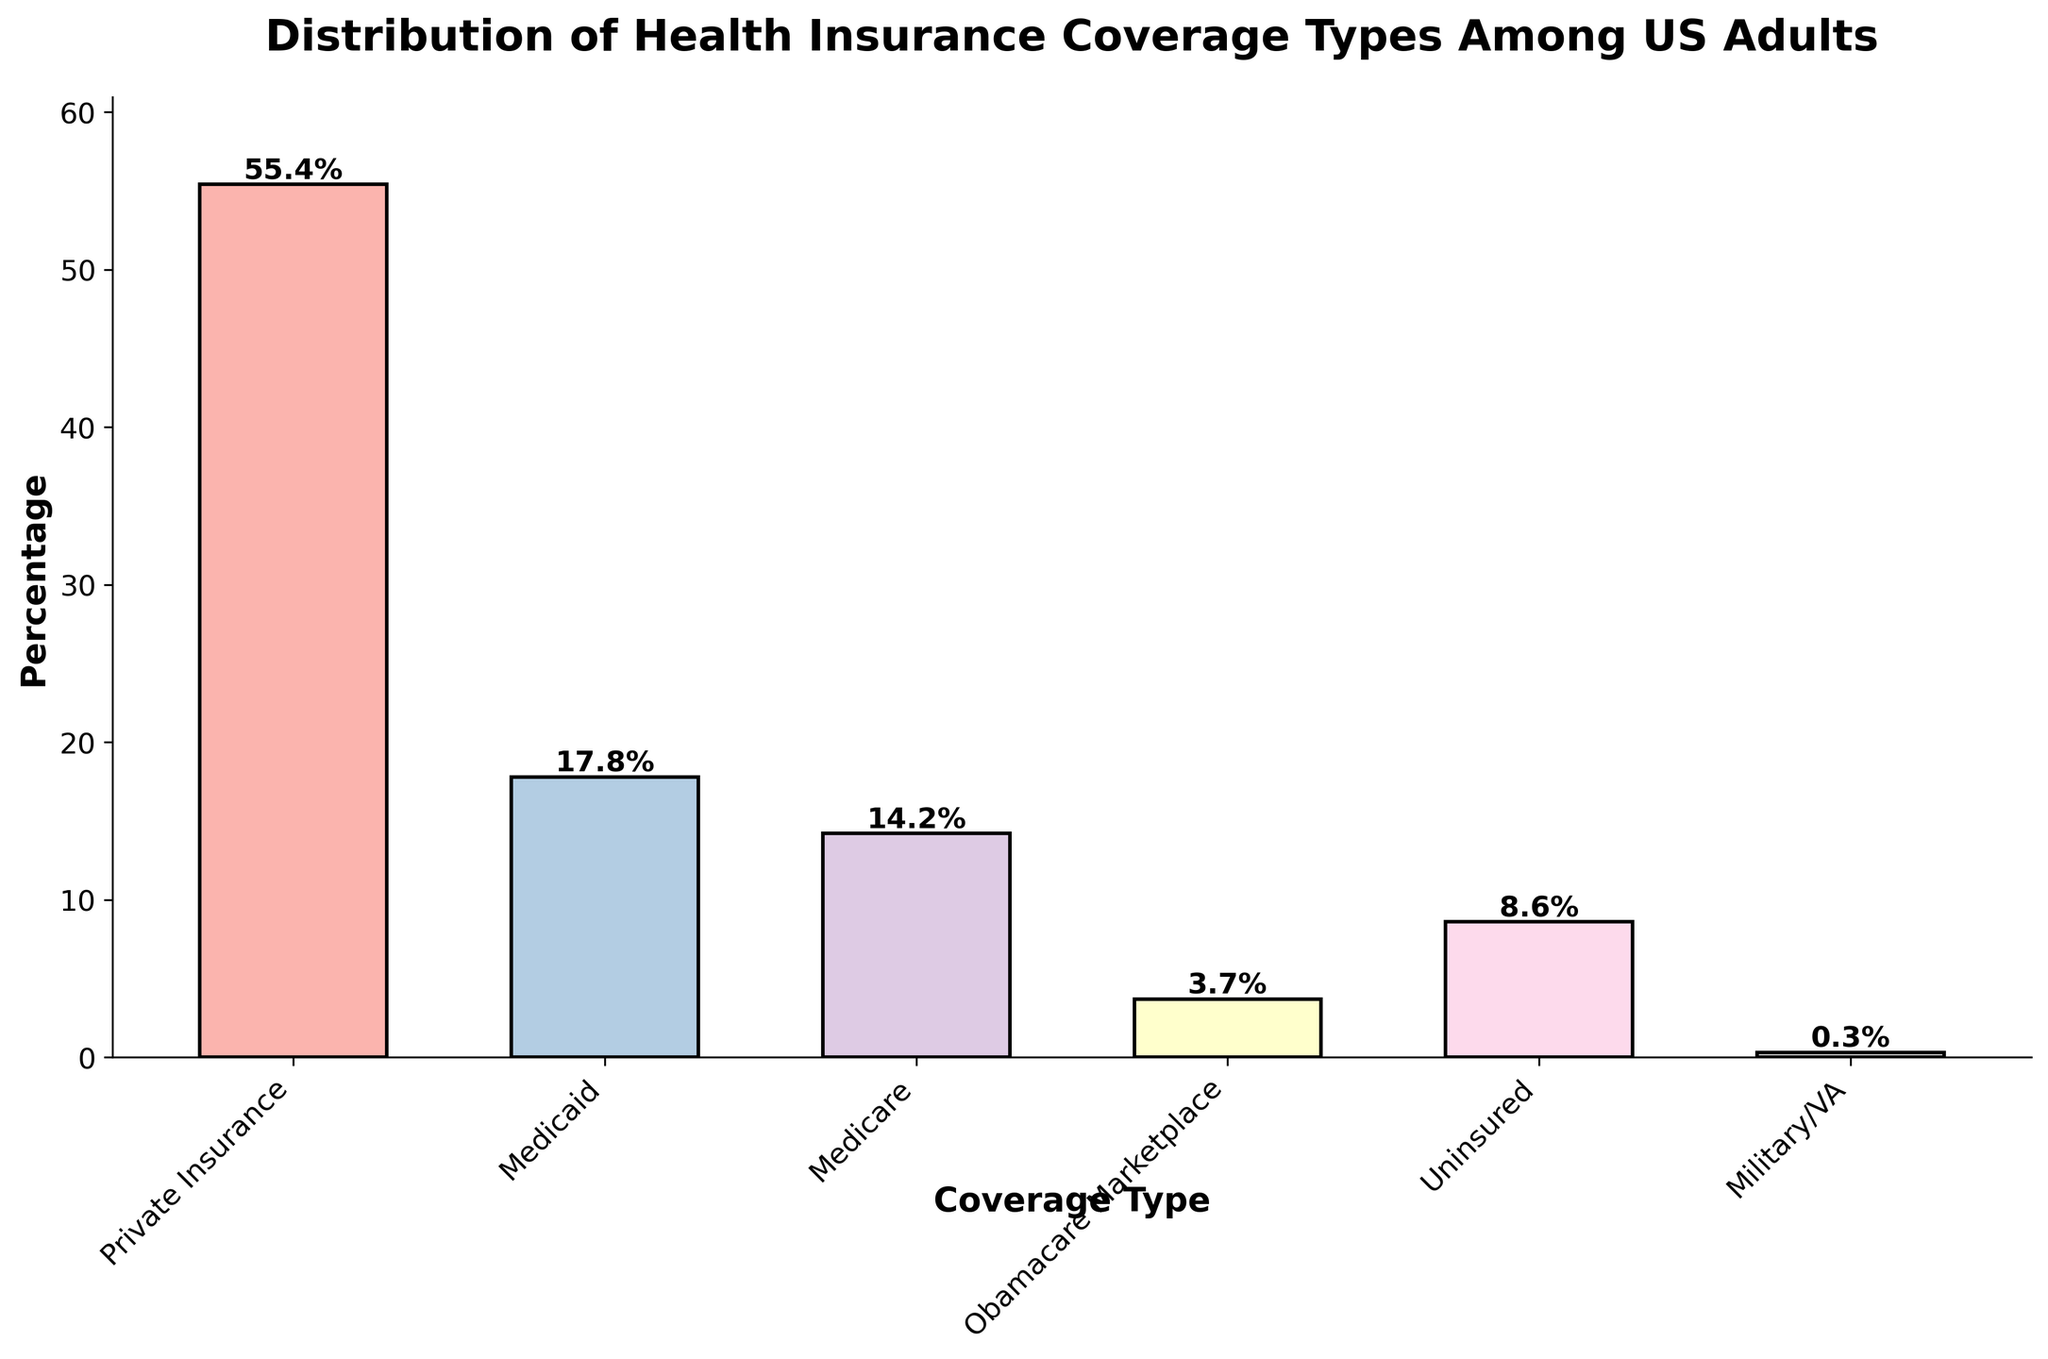What is the title of the figure? The title is prominently displayed at the top of the figure, describing the main content and context of the plot.
Answer: Distribution of Health Insurance Coverage Types Among US Adults What is the percentage of US adults with Medicaid coverage? The percentage for Medicaid coverage can be read directly from the height of the bar labeled "Medicaid." It is annotated on top of the bar.
Answer: 17.8% Which health insurance coverage type has the highest percentage of US adults? To determine the health insurance coverage with the highest percentage, identify the tallest bar in the histogram and read its label. The tallest bar is labeled "Private Insurance."
Answer: Private Insurance How does the percentage of Obamacare Marketplace enrollees compare to those uninsured? Compare the heights of the bars labeled "Obamacare Marketplace" and "Uninsured." The "Uninsured" bar is higher than the "Obamacare Marketplace" bar. Obamacare Marketplace has a lower percentage.
Answer: Obamacare Marketplace has a lower percentage What is the combined percentage of US adults covered by Medicare and Military/VA? Add the percentages of the bars labeled "Medicare" and "Military/VA." The percentages are 14.2% for Medicare and 0.3% for Military/VA. Total = 14.2% + 0.3% = 14.5%.
Answer: 14.5% Which coverage type represents less than 1% of US adults? Identify the bar with a height representing less than 1% and read its label. The bar labeled "Military/VA" fits this criterion.
Answer: Military/VA By what percentage is Private Insurance coverage higher than Medicaid coverage? Subtract the percentage of Medicaid coverage from the Private Insurance coverage. Private Insurance is 55.4%, and Medicaid is 17.8%. 55.4% - 17.8% = 37.6%
Answer: 37.6% What is the total percentage of US adults covered by any form of health insurance (Private Insurance, Medicaid, Medicare, Obamacare Marketplace, Military/VA)? Add the percentages of all the types except "Uninsured": 55.4% (Private Insurance) + 17.8% (Medicaid) + 14.2% (Medicare) + 3.7% (Obamacare Marketplace) + 0.3% (Military/VA) = 91.4%.
Answer: 91.4% What is the least common coverage type among US adults? Identify the shortest bar in the histogram, which indicates the smallest percentage. The shortest bar is labeled "Military/VA."
Answer: Military/VA How much higher is the percentage of adults with Private Insurance than the combined percentage of those with Medicare and Medicaid? Sum the percentages for Medicare and Medicaid: 14.2% + 17.8% = 32%. Then, subtract this sum from the Private Insurance percentage: 55.4% - 32% = 23.4%.
Answer: 23.4% 